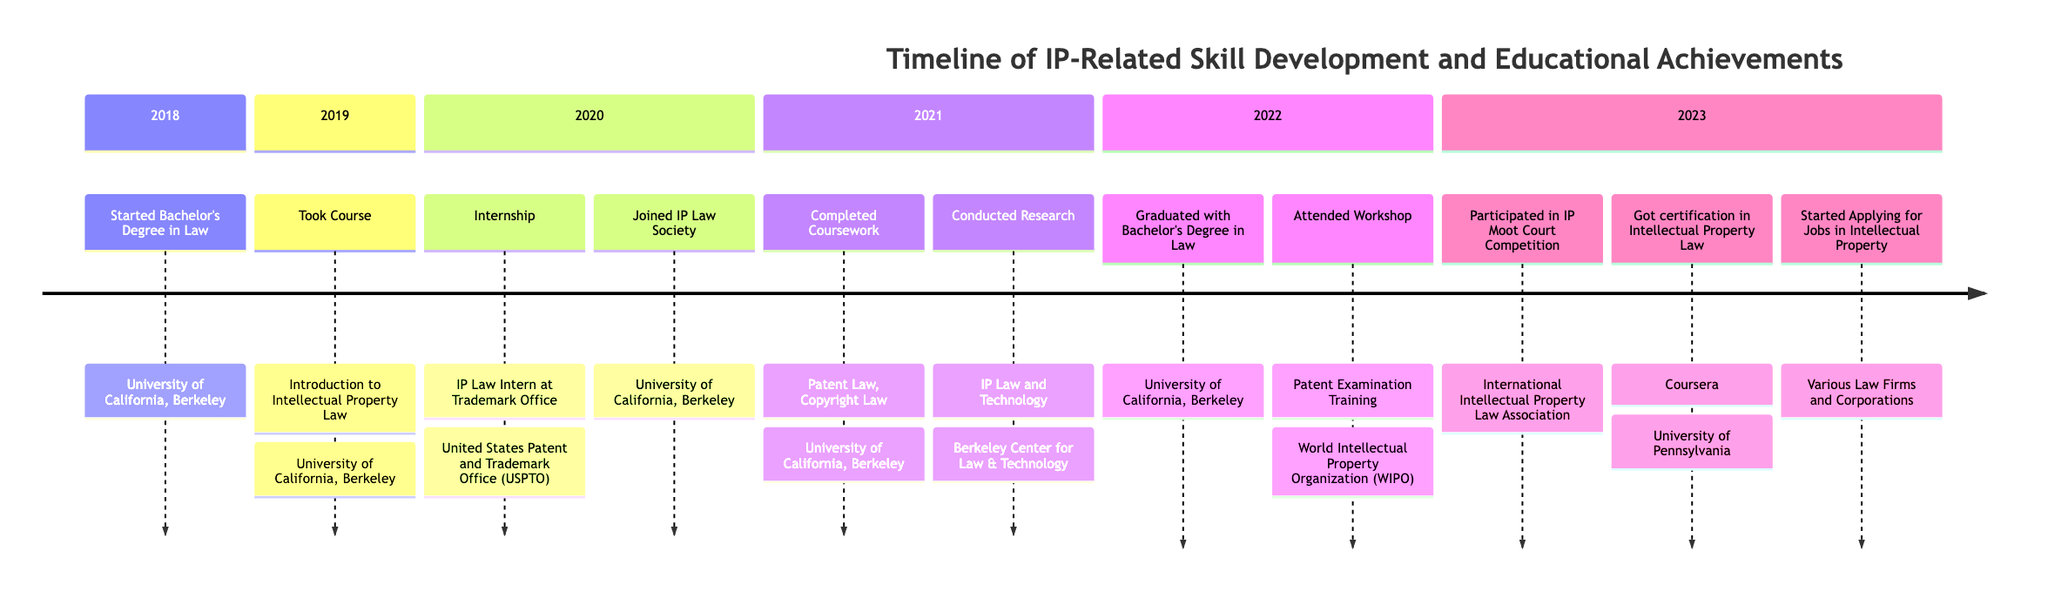What year did you start your Bachelor's Degree in Law? The timeline indicates that the event "Started Bachelor's Degree in Law" occurred in the year 2018.
Answer: 2018 What course was taken in 2019? The timeline shows that in 2019, the event "Took Course: Introduction to Intellectual Property Law" took place at the University of California, Berkeley.
Answer: Introduction to Intellectual Property Law How many events are listed for the year 2022? The timeline presents two events for the year 2022, which are "Graduated with Bachelor's Degree in Law" and "Attended Workshop: Patent Examination Training."
Answer: 2 In which year did you conduct research related to IP law? According to the timeline, the research was conducted in the year 2021 under the event “Conducted Research: IP Law and Technology.”
Answer: 2021 Which institution hosted the Patent Examination Training workshop? The timeline specifies that the "Attended Workshop: Patent Examination Training" occurred at the World Intellectual Property Organization (WIPO).
Answer: World Intellectual Property Organization What was the last event listed on the timeline? The final event in the timeline is "Started Applying for Jobs in Intellectual Property," which occurred in the year 2023.
Answer: Started Applying for Jobs in Intellectual Property Which two skills related to IP law were completed in 2021? The timeline indicates that in 2021, the events "Completed Coursework: Patent Law, Copyright Law" occurred, referencing two specific areas of skill development.
Answer: Patent Law, Copyright Law How many total skills or achievements are displayed for the year 2023? In 2023, the timeline shows three distinct events: "Participated in IP Moot Court Competition," "Got certification in Intellectual Property Law," and "Started Applying for Jobs in Intellectual Property." Hence, there are three achievements.
Answer: 3 What was the purpose of joining the IP Law Society in 2020? The timeline records that in 2020, the event "Joined IP Law Society" contributed to networking and collaboration among peers interested in IP law, although the purpose isn't explicitly stated, joining such societies typically aims to enhance understanding and engagement in the field.
Answer: Networking and collaboration 